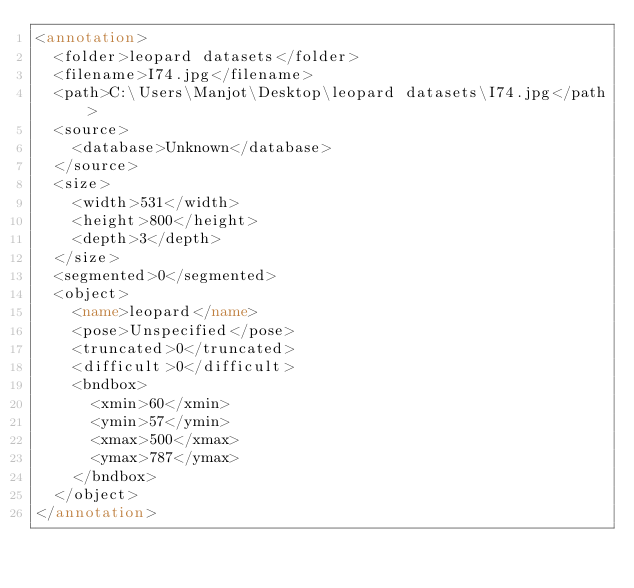<code> <loc_0><loc_0><loc_500><loc_500><_XML_><annotation>
	<folder>leopard datasets</folder>
	<filename>I74.jpg</filename>
	<path>C:\Users\Manjot\Desktop\leopard datasets\I74.jpg</path>
	<source>
		<database>Unknown</database>
	</source>
	<size>
		<width>531</width>
		<height>800</height>
		<depth>3</depth>
	</size>
	<segmented>0</segmented>
	<object>
		<name>leopard</name>
		<pose>Unspecified</pose>
		<truncated>0</truncated>
		<difficult>0</difficult>
		<bndbox>
			<xmin>60</xmin>
			<ymin>57</ymin>
			<xmax>500</xmax>
			<ymax>787</ymax>
		</bndbox>
	</object>
</annotation>
</code> 